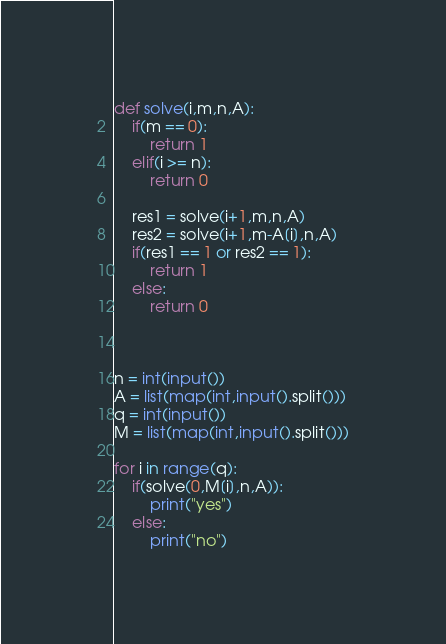<code> <loc_0><loc_0><loc_500><loc_500><_Python_>def solve(i,m,n,A):
    if(m == 0):
        return 1
    elif(i >= n):
        return 0

    res1 = solve(i+1,m,n,A)
    res2 = solve(i+1,m-A[i],n,A)
    if(res1 == 1 or res2 == 1):
        return 1
    else:
        return 0



n = int(input())
A = list(map(int,input().split()))
q = int(input())
M = list(map(int,input().split()))

for i in range(q):
    if(solve(0,M[i],n,A)):
        print("yes")
    else:
        print("no")
</code> 